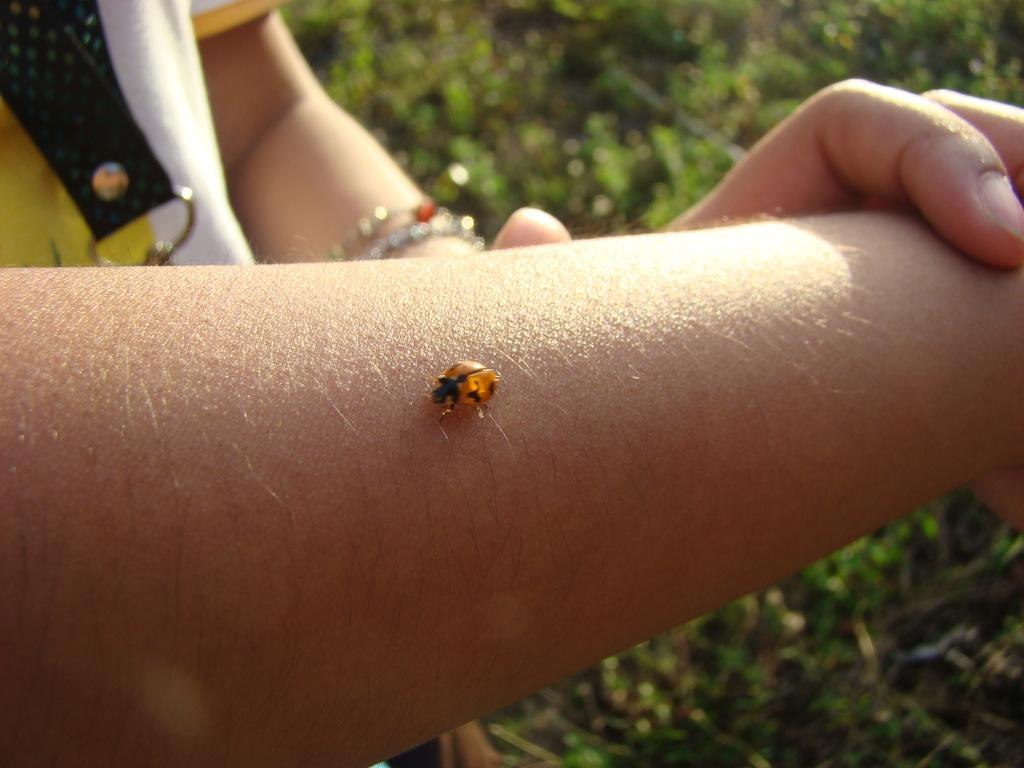What type of vegetation can be seen in the image? There is grass in the image. Can you describe the person in the image? There is a person in the image. What is the insect doing in the image? The insect is present on the person's hand. What type of bead is the person wearing around their neck in the image? There is no mention of a bead or any jewelry in the image. Where is the seat located in the image? There is no mention of a seat in the image. 